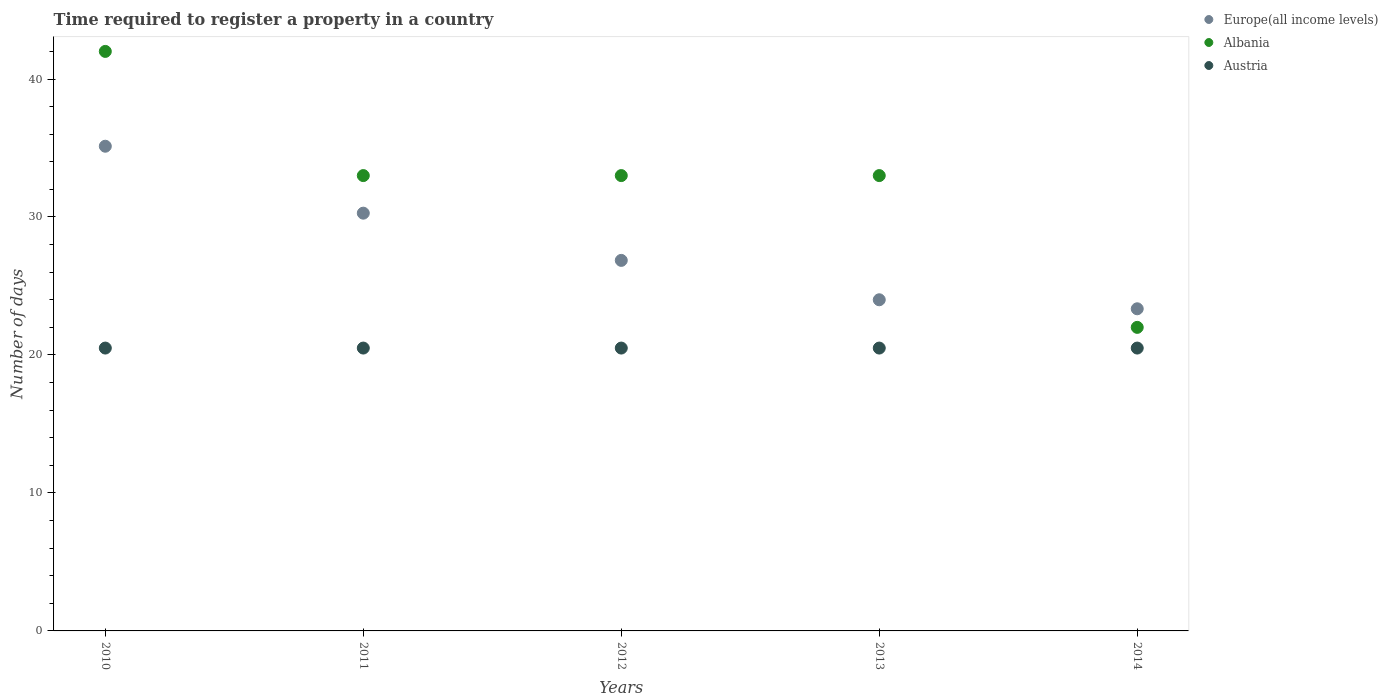Is the number of dotlines equal to the number of legend labels?
Your response must be concise. Yes. What is the number of days required to register a property in Albania in 2014?
Keep it short and to the point. 22. What is the total number of days required to register a property in Austria in the graph?
Your answer should be very brief. 102.5. What is the difference between the number of days required to register a property in Austria in 2010 and that in 2011?
Provide a short and direct response. 0. What is the difference between the number of days required to register a property in Albania in 2011 and the number of days required to register a property in Europe(all income levels) in 2010?
Give a very brief answer. -2.13. In the year 2014, what is the difference between the number of days required to register a property in Albania and number of days required to register a property in Europe(all income levels)?
Your answer should be compact. -1.35. In how many years, is the number of days required to register a property in Europe(all income levels) greater than 40 days?
Your answer should be very brief. 0. Is the number of days required to register a property in Albania in 2012 less than that in 2013?
Ensure brevity in your answer.  No. Is the difference between the number of days required to register a property in Albania in 2011 and 2014 greater than the difference between the number of days required to register a property in Europe(all income levels) in 2011 and 2014?
Your response must be concise. Yes. What is the difference between the highest and the second highest number of days required to register a property in Europe(all income levels)?
Keep it short and to the point. 4.85. What is the difference between the highest and the lowest number of days required to register a property in Albania?
Ensure brevity in your answer.  20. Does the number of days required to register a property in Albania monotonically increase over the years?
Provide a short and direct response. No. Is the number of days required to register a property in Austria strictly greater than the number of days required to register a property in Europe(all income levels) over the years?
Keep it short and to the point. No. Is the number of days required to register a property in Austria strictly less than the number of days required to register a property in Europe(all income levels) over the years?
Give a very brief answer. Yes. How many years are there in the graph?
Make the answer very short. 5. What is the difference between two consecutive major ticks on the Y-axis?
Your answer should be very brief. 10. Are the values on the major ticks of Y-axis written in scientific E-notation?
Provide a short and direct response. No. Does the graph contain grids?
Provide a succinct answer. No. How many legend labels are there?
Your response must be concise. 3. How are the legend labels stacked?
Your answer should be very brief. Vertical. What is the title of the graph?
Offer a very short reply. Time required to register a property in a country. What is the label or title of the Y-axis?
Ensure brevity in your answer.  Number of days. What is the Number of days of Europe(all income levels) in 2010?
Provide a succinct answer. 35.13. What is the Number of days in Austria in 2010?
Make the answer very short. 20.5. What is the Number of days of Europe(all income levels) in 2011?
Give a very brief answer. 30.28. What is the Number of days of Albania in 2011?
Your response must be concise. 33. What is the Number of days of Austria in 2011?
Provide a short and direct response. 20.5. What is the Number of days in Europe(all income levels) in 2012?
Offer a very short reply. 26.85. What is the Number of days of Albania in 2012?
Offer a terse response. 33. What is the Number of days in Austria in 2012?
Offer a very short reply. 20.5. What is the Number of days in Europe(all income levels) in 2013?
Your answer should be compact. 24. What is the Number of days in Europe(all income levels) in 2014?
Your answer should be compact. 23.35. What is the Number of days of Albania in 2014?
Offer a very short reply. 22. Across all years, what is the maximum Number of days of Europe(all income levels)?
Give a very brief answer. 35.13. Across all years, what is the maximum Number of days of Albania?
Give a very brief answer. 42. Across all years, what is the minimum Number of days in Europe(all income levels)?
Your response must be concise. 23.35. What is the total Number of days in Europe(all income levels) in the graph?
Your answer should be compact. 139.61. What is the total Number of days in Albania in the graph?
Your answer should be compact. 163. What is the total Number of days in Austria in the graph?
Provide a succinct answer. 102.5. What is the difference between the Number of days in Europe(all income levels) in 2010 and that in 2011?
Keep it short and to the point. 4.85. What is the difference between the Number of days in Albania in 2010 and that in 2011?
Provide a succinct answer. 9. What is the difference between the Number of days in Austria in 2010 and that in 2011?
Provide a succinct answer. 0. What is the difference between the Number of days of Europe(all income levels) in 2010 and that in 2012?
Your answer should be compact. 8.27. What is the difference between the Number of days in Albania in 2010 and that in 2012?
Offer a terse response. 9. What is the difference between the Number of days of Europe(all income levels) in 2010 and that in 2013?
Ensure brevity in your answer.  11.13. What is the difference between the Number of days in Europe(all income levels) in 2010 and that in 2014?
Your answer should be very brief. 11.78. What is the difference between the Number of days in Europe(all income levels) in 2011 and that in 2012?
Keep it short and to the point. 3.42. What is the difference between the Number of days in Austria in 2011 and that in 2012?
Offer a terse response. 0. What is the difference between the Number of days in Europe(all income levels) in 2011 and that in 2013?
Ensure brevity in your answer.  6.28. What is the difference between the Number of days in Austria in 2011 and that in 2013?
Offer a very short reply. 0. What is the difference between the Number of days in Europe(all income levels) in 2011 and that in 2014?
Keep it short and to the point. 6.93. What is the difference between the Number of days of Europe(all income levels) in 2012 and that in 2013?
Your answer should be compact. 2.85. What is the difference between the Number of days of Austria in 2012 and that in 2013?
Give a very brief answer. 0. What is the difference between the Number of days in Europe(all income levels) in 2012 and that in 2014?
Your answer should be compact. 3.51. What is the difference between the Number of days in Austria in 2012 and that in 2014?
Give a very brief answer. 0. What is the difference between the Number of days of Europe(all income levels) in 2013 and that in 2014?
Keep it short and to the point. 0.65. What is the difference between the Number of days in Albania in 2013 and that in 2014?
Ensure brevity in your answer.  11. What is the difference between the Number of days of Austria in 2013 and that in 2014?
Provide a short and direct response. 0. What is the difference between the Number of days of Europe(all income levels) in 2010 and the Number of days of Albania in 2011?
Your answer should be very brief. 2.13. What is the difference between the Number of days of Europe(all income levels) in 2010 and the Number of days of Austria in 2011?
Ensure brevity in your answer.  14.63. What is the difference between the Number of days in Albania in 2010 and the Number of days in Austria in 2011?
Offer a terse response. 21.5. What is the difference between the Number of days of Europe(all income levels) in 2010 and the Number of days of Albania in 2012?
Your answer should be compact. 2.13. What is the difference between the Number of days in Europe(all income levels) in 2010 and the Number of days in Austria in 2012?
Your response must be concise. 14.63. What is the difference between the Number of days of Albania in 2010 and the Number of days of Austria in 2012?
Ensure brevity in your answer.  21.5. What is the difference between the Number of days of Europe(all income levels) in 2010 and the Number of days of Albania in 2013?
Your response must be concise. 2.13. What is the difference between the Number of days in Europe(all income levels) in 2010 and the Number of days in Austria in 2013?
Provide a succinct answer. 14.63. What is the difference between the Number of days of Europe(all income levels) in 2010 and the Number of days of Albania in 2014?
Your answer should be very brief. 13.13. What is the difference between the Number of days of Europe(all income levels) in 2010 and the Number of days of Austria in 2014?
Your response must be concise. 14.63. What is the difference between the Number of days in Europe(all income levels) in 2011 and the Number of days in Albania in 2012?
Provide a short and direct response. -2.72. What is the difference between the Number of days of Europe(all income levels) in 2011 and the Number of days of Austria in 2012?
Provide a short and direct response. 9.78. What is the difference between the Number of days in Albania in 2011 and the Number of days in Austria in 2012?
Offer a very short reply. 12.5. What is the difference between the Number of days of Europe(all income levels) in 2011 and the Number of days of Albania in 2013?
Give a very brief answer. -2.72. What is the difference between the Number of days of Europe(all income levels) in 2011 and the Number of days of Austria in 2013?
Provide a succinct answer. 9.78. What is the difference between the Number of days of Albania in 2011 and the Number of days of Austria in 2013?
Your answer should be compact. 12.5. What is the difference between the Number of days of Europe(all income levels) in 2011 and the Number of days of Albania in 2014?
Provide a succinct answer. 8.28. What is the difference between the Number of days of Europe(all income levels) in 2011 and the Number of days of Austria in 2014?
Your answer should be compact. 9.78. What is the difference between the Number of days of Europe(all income levels) in 2012 and the Number of days of Albania in 2013?
Make the answer very short. -6.15. What is the difference between the Number of days of Europe(all income levels) in 2012 and the Number of days of Austria in 2013?
Provide a short and direct response. 6.35. What is the difference between the Number of days of Europe(all income levels) in 2012 and the Number of days of Albania in 2014?
Provide a short and direct response. 4.85. What is the difference between the Number of days of Europe(all income levels) in 2012 and the Number of days of Austria in 2014?
Keep it short and to the point. 6.35. What is the difference between the Number of days of Europe(all income levels) in 2013 and the Number of days of Albania in 2014?
Keep it short and to the point. 2. What is the difference between the Number of days of Europe(all income levels) in 2013 and the Number of days of Austria in 2014?
Give a very brief answer. 3.5. What is the average Number of days in Europe(all income levels) per year?
Your answer should be compact. 27.92. What is the average Number of days in Albania per year?
Offer a terse response. 32.6. What is the average Number of days of Austria per year?
Offer a terse response. 20.5. In the year 2010, what is the difference between the Number of days in Europe(all income levels) and Number of days in Albania?
Your response must be concise. -6.87. In the year 2010, what is the difference between the Number of days of Europe(all income levels) and Number of days of Austria?
Your answer should be very brief. 14.63. In the year 2010, what is the difference between the Number of days in Albania and Number of days in Austria?
Provide a short and direct response. 21.5. In the year 2011, what is the difference between the Number of days in Europe(all income levels) and Number of days in Albania?
Give a very brief answer. -2.72. In the year 2011, what is the difference between the Number of days of Europe(all income levels) and Number of days of Austria?
Your answer should be very brief. 9.78. In the year 2011, what is the difference between the Number of days in Albania and Number of days in Austria?
Your answer should be compact. 12.5. In the year 2012, what is the difference between the Number of days of Europe(all income levels) and Number of days of Albania?
Offer a terse response. -6.15. In the year 2012, what is the difference between the Number of days in Europe(all income levels) and Number of days in Austria?
Keep it short and to the point. 6.35. In the year 2012, what is the difference between the Number of days of Albania and Number of days of Austria?
Ensure brevity in your answer.  12.5. In the year 2013, what is the difference between the Number of days in Europe(all income levels) and Number of days in Albania?
Your answer should be compact. -9. In the year 2013, what is the difference between the Number of days in Europe(all income levels) and Number of days in Austria?
Your response must be concise. 3.5. In the year 2013, what is the difference between the Number of days in Albania and Number of days in Austria?
Offer a very short reply. 12.5. In the year 2014, what is the difference between the Number of days in Europe(all income levels) and Number of days in Albania?
Your answer should be compact. 1.35. In the year 2014, what is the difference between the Number of days in Europe(all income levels) and Number of days in Austria?
Provide a short and direct response. 2.85. What is the ratio of the Number of days of Europe(all income levels) in 2010 to that in 2011?
Offer a terse response. 1.16. What is the ratio of the Number of days in Albania in 2010 to that in 2011?
Your response must be concise. 1.27. What is the ratio of the Number of days in Europe(all income levels) in 2010 to that in 2012?
Your response must be concise. 1.31. What is the ratio of the Number of days of Albania in 2010 to that in 2012?
Provide a succinct answer. 1.27. What is the ratio of the Number of days of Europe(all income levels) in 2010 to that in 2013?
Offer a terse response. 1.46. What is the ratio of the Number of days of Albania in 2010 to that in 2013?
Provide a succinct answer. 1.27. What is the ratio of the Number of days of Europe(all income levels) in 2010 to that in 2014?
Provide a short and direct response. 1.5. What is the ratio of the Number of days of Albania in 2010 to that in 2014?
Your answer should be very brief. 1.91. What is the ratio of the Number of days in Europe(all income levels) in 2011 to that in 2012?
Your answer should be very brief. 1.13. What is the ratio of the Number of days in Austria in 2011 to that in 2012?
Your answer should be very brief. 1. What is the ratio of the Number of days of Europe(all income levels) in 2011 to that in 2013?
Your answer should be very brief. 1.26. What is the ratio of the Number of days in Austria in 2011 to that in 2013?
Your answer should be very brief. 1. What is the ratio of the Number of days in Europe(all income levels) in 2011 to that in 2014?
Ensure brevity in your answer.  1.3. What is the ratio of the Number of days in Europe(all income levels) in 2012 to that in 2013?
Your answer should be very brief. 1.12. What is the ratio of the Number of days in Austria in 2012 to that in 2013?
Your answer should be very brief. 1. What is the ratio of the Number of days in Europe(all income levels) in 2012 to that in 2014?
Ensure brevity in your answer.  1.15. What is the ratio of the Number of days in Austria in 2012 to that in 2014?
Your response must be concise. 1. What is the ratio of the Number of days in Europe(all income levels) in 2013 to that in 2014?
Offer a terse response. 1.03. What is the difference between the highest and the second highest Number of days in Europe(all income levels)?
Offer a very short reply. 4.85. What is the difference between the highest and the second highest Number of days of Austria?
Give a very brief answer. 0. What is the difference between the highest and the lowest Number of days of Europe(all income levels)?
Provide a succinct answer. 11.78. 